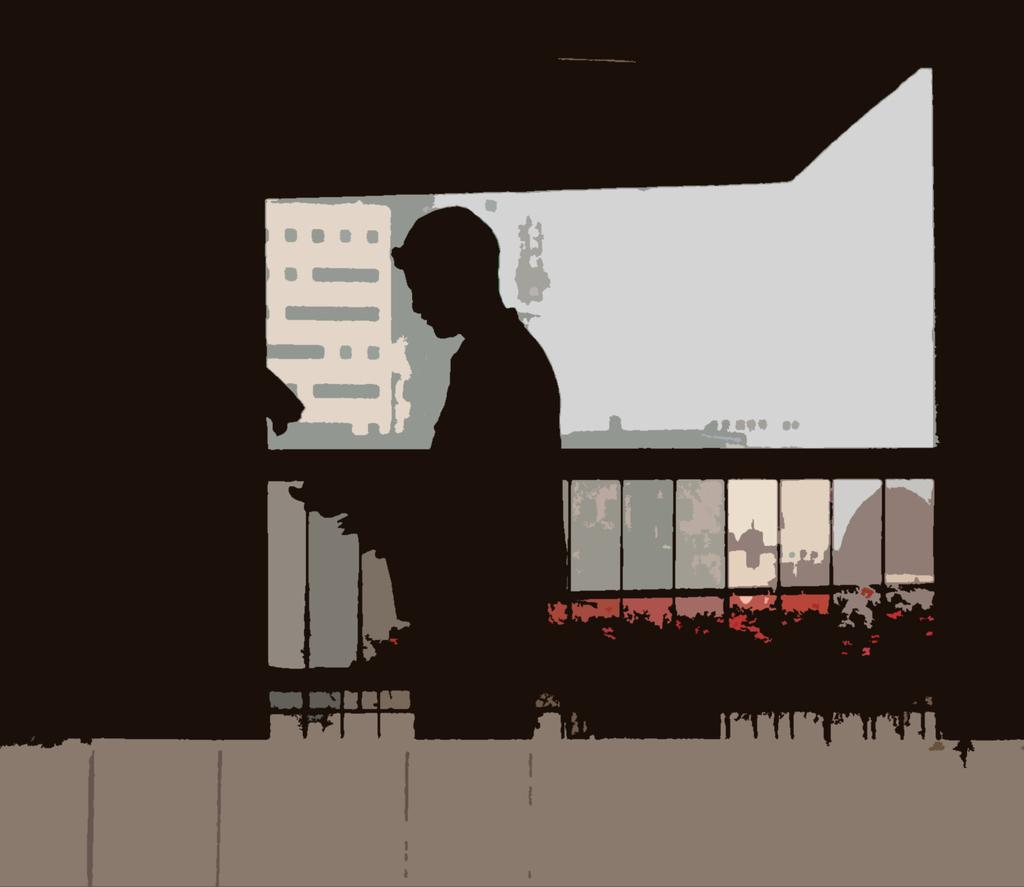What is the main subject of the painting in the image? The painting features a person standing in the center. What can be seen in the background of the painting? There are buildings, a fence, and plants in the background of the painting. What type of alley can be seen behind the person in the painting? There is no alley present in the painting; it features a person standing in the center with buildings, a fence, and plants in the background. 